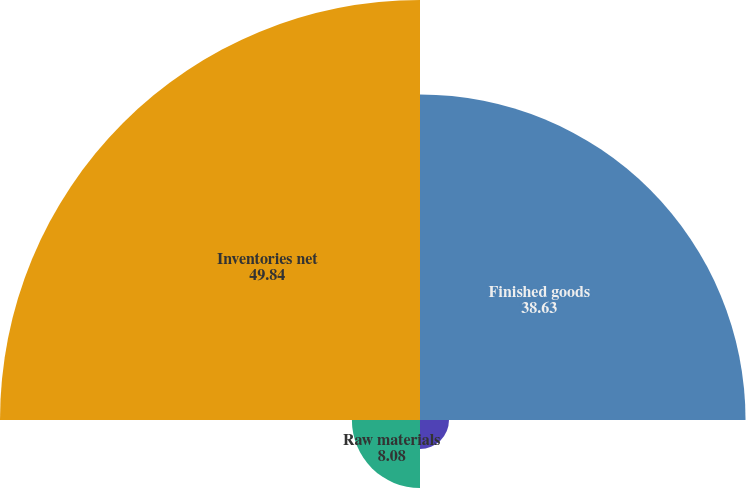Convert chart. <chart><loc_0><loc_0><loc_500><loc_500><pie_chart><fcel>Finished goods<fcel>Work in progress<fcel>Raw materials<fcel>Inventories net<nl><fcel>38.63%<fcel>3.44%<fcel>8.08%<fcel>49.84%<nl></chart> 